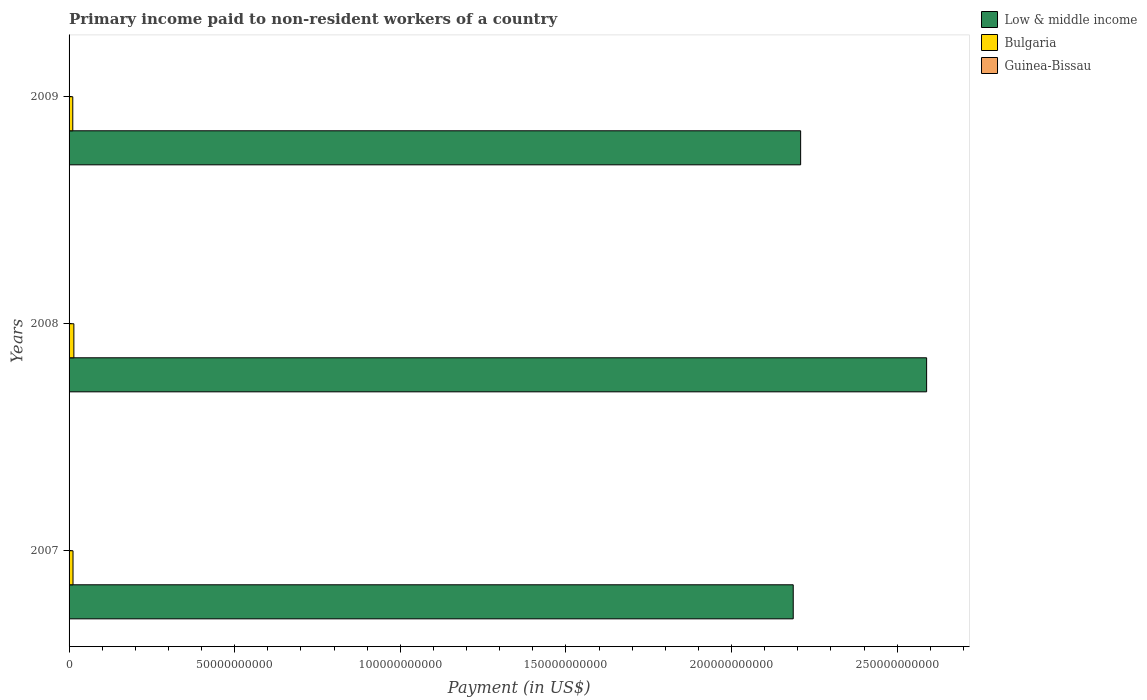Are the number of bars on each tick of the Y-axis equal?
Keep it short and to the point. Yes. How many bars are there on the 3rd tick from the top?
Your answer should be very brief. 3. How many bars are there on the 2nd tick from the bottom?
Make the answer very short. 3. What is the label of the 2nd group of bars from the top?
Make the answer very short. 2008. In how many cases, is the number of bars for a given year not equal to the number of legend labels?
Provide a short and direct response. 0. What is the amount paid to workers in Bulgaria in 2007?
Offer a very short reply. 1.19e+09. Across all years, what is the maximum amount paid to workers in Low & middle income?
Your response must be concise. 2.59e+11. Across all years, what is the minimum amount paid to workers in Low & middle income?
Your response must be concise. 2.19e+11. In which year was the amount paid to workers in Guinea-Bissau maximum?
Your answer should be very brief. 2009. In which year was the amount paid to workers in Low & middle income minimum?
Offer a very short reply. 2007. What is the total amount paid to workers in Guinea-Bissau in the graph?
Offer a very short reply. 9.26e+06. What is the difference between the amount paid to workers in Guinea-Bissau in 2007 and that in 2008?
Make the answer very short. 2.60e+05. What is the difference between the amount paid to workers in Low & middle income in 2009 and the amount paid to workers in Guinea-Bissau in 2007?
Offer a terse response. 2.21e+11. What is the average amount paid to workers in Guinea-Bissau per year?
Ensure brevity in your answer.  3.09e+06. In the year 2007, what is the difference between the amount paid to workers in Guinea-Bissau and amount paid to workers in Low & middle income?
Offer a very short reply. -2.19e+11. What is the ratio of the amount paid to workers in Low & middle income in 2008 to that in 2009?
Offer a terse response. 1.17. Is the amount paid to workers in Bulgaria in 2007 less than that in 2009?
Your answer should be very brief. No. What is the difference between the highest and the second highest amount paid to workers in Guinea-Bissau?
Your response must be concise. 8.20e+06. What is the difference between the highest and the lowest amount paid to workers in Guinea-Bissau?
Keep it short and to the point. 8.46e+06. Is the sum of the amount paid to workers in Low & middle income in 2007 and 2008 greater than the maximum amount paid to workers in Bulgaria across all years?
Offer a very short reply. Yes. What does the 2nd bar from the top in 2009 represents?
Make the answer very short. Bulgaria. What does the 3rd bar from the bottom in 2008 represents?
Provide a short and direct response. Guinea-Bissau. How many bars are there?
Offer a terse response. 9. How many years are there in the graph?
Offer a terse response. 3. What is the difference between two consecutive major ticks on the X-axis?
Your answer should be compact. 5.00e+1. Are the values on the major ticks of X-axis written in scientific E-notation?
Make the answer very short. No. How many legend labels are there?
Your response must be concise. 3. How are the legend labels stacked?
Make the answer very short. Vertical. What is the title of the graph?
Offer a very short reply. Primary income paid to non-resident workers of a country. What is the label or title of the X-axis?
Give a very brief answer. Payment (in US$). What is the Payment (in US$) of Low & middle income in 2007?
Ensure brevity in your answer.  2.19e+11. What is the Payment (in US$) in Bulgaria in 2007?
Offer a very short reply. 1.19e+09. What is the Payment (in US$) in Guinea-Bissau in 2007?
Offer a very short reply. 4.40e+05. What is the Payment (in US$) in Low & middle income in 2008?
Keep it short and to the point. 2.59e+11. What is the Payment (in US$) in Bulgaria in 2008?
Make the answer very short. 1.45e+09. What is the Payment (in US$) in Guinea-Bissau in 2008?
Your answer should be compact. 1.80e+05. What is the Payment (in US$) in Low & middle income in 2009?
Keep it short and to the point. 2.21e+11. What is the Payment (in US$) of Bulgaria in 2009?
Your answer should be very brief. 1.12e+09. What is the Payment (in US$) in Guinea-Bissau in 2009?
Give a very brief answer. 8.64e+06. Across all years, what is the maximum Payment (in US$) of Low & middle income?
Give a very brief answer. 2.59e+11. Across all years, what is the maximum Payment (in US$) of Bulgaria?
Offer a very short reply. 1.45e+09. Across all years, what is the maximum Payment (in US$) in Guinea-Bissau?
Ensure brevity in your answer.  8.64e+06. Across all years, what is the minimum Payment (in US$) in Low & middle income?
Offer a very short reply. 2.19e+11. Across all years, what is the minimum Payment (in US$) of Bulgaria?
Give a very brief answer. 1.12e+09. Across all years, what is the minimum Payment (in US$) of Guinea-Bissau?
Your answer should be very brief. 1.80e+05. What is the total Payment (in US$) in Low & middle income in the graph?
Make the answer very short. 6.98e+11. What is the total Payment (in US$) in Bulgaria in the graph?
Give a very brief answer. 3.76e+09. What is the total Payment (in US$) in Guinea-Bissau in the graph?
Offer a terse response. 9.26e+06. What is the difference between the Payment (in US$) in Low & middle income in 2007 and that in 2008?
Make the answer very short. -4.03e+1. What is the difference between the Payment (in US$) of Bulgaria in 2007 and that in 2008?
Provide a succinct answer. -2.61e+08. What is the difference between the Payment (in US$) of Guinea-Bissau in 2007 and that in 2008?
Offer a terse response. 2.60e+05. What is the difference between the Payment (in US$) of Low & middle income in 2007 and that in 2009?
Make the answer very short. -2.24e+09. What is the difference between the Payment (in US$) in Bulgaria in 2007 and that in 2009?
Provide a short and direct response. 6.98e+07. What is the difference between the Payment (in US$) in Guinea-Bissau in 2007 and that in 2009?
Your answer should be compact. -8.20e+06. What is the difference between the Payment (in US$) in Low & middle income in 2008 and that in 2009?
Your response must be concise. 3.80e+1. What is the difference between the Payment (in US$) in Bulgaria in 2008 and that in 2009?
Ensure brevity in your answer.  3.31e+08. What is the difference between the Payment (in US$) in Guinea-Bissau in 2008 and that in 2009?
Offer a terse response. -8.46e+06. What is the difference between the Payment (in US$) of Low & middle income in 2007 and the Payment (in US$) of Bulgaria in 2008?
Provide a short and direct response. 2.17e+11. What is the difference between the Payment (in US$) in Low & middle income in 2007 and the Payment (in US$) in Guinea-Bissau in 2008?
Your response must be concise. 2.19e+11. What is the difference between the Payment (in US$) of Bulgaria in 2007 and the Payment (in US$) of Guinea-Bissau in 2008?
Offer a very short reply. 1.19e+09. What is the difference between the Payment (in US$) in Low & middle income in 2007 and the Payment (in US$) in Bulgaria in 2009?
Offer a very short reply. 2.18e+11. What is the difference between the Payment (in US$) of Low & middle income in 2007 and the Payment (in US$) of Guinea-Bissau in 2009?
Provide a short and direct response. 2.19e+11. What is the difference between the Payment (in US$) of Bulgaria in 2007 and the Payment (in US$) of Guinea-Bissau in 2009?
Provide a short and direct response. 1.18e+09. What is the difference between the Payment (in US$) of Low & middle income in 2008 and the Payment (in US$) of Bulgaria in 2009?
Your answer should be very brief. 2.58e+11. What is the difference between the Payment (in US$) of Low & middle income in 2008 and the Payment (in US$) of Guinea-Bissau in 2009?
Offer a terse response. 2.59e+11. What is the difference between the Payment (in US$) in Bulgaria in 2008 and the Payment (in US$) in Guinea-Bissau in 2009?
Your answer should be compact. 1.44e+09. What is the average Payment (in US$) in Low & middle income per year?
Give a very brief answer. 2.33e+11. What is the average Payment (in US$) in Bulgaria per year?
Offer a very short reply. 1.25e+09. What is the average Payment (in US$) in Guinea-Bissau per year?
Offer a very short reply. 3.09e+06. In the year 2007, what is the difference between the Payment (in US$) of Low & middle income and Payment (in US$) of Bulgaria?
Offer a terse response. 2.17e+11. In the year 2007, what is the difference between the Payment (in US$) of Low & middle income and Payment (in US$) of Guinea-Bissau?
Keep it short and to the point. 2.19e+11. In the year 2007, what is the difference between the Payment (in US$) of Bulgaria and Payment (in US$) of Guinea-Bissau?
Provide a short and direct response. 1.19e+09. In the year 2008, what is the difference between the Payment (in US$) in Low & middle income and Payment (in US$) in Bulgaria?
Ensure brevity in your answer.  2.57e+11. In the year 2008, what is the difference between the Payment (in US$) in Low & middle income and Payment (in US$) in Guinea-Bissau?
Keep it short and to the point. 2.59e+11. In the year 2008, what is the difference between the Payment (in US$) of Bulgaria and Payment (in US$) of Guinea-Bissau?
Make the answer very short. 1.45e+09. In the year 2009, what is the difference between the Payment (in US$) of Low & middle income and Payment (in US$) of Bulgaria?
Your answer should be very brief. 2.20e+11. In the year 2009, what is the difference between the Payment (in US$) of Low & middle income and Payment (in US$) of Guinea-Bissau?
Your answer should be compact. 2.21e+11. In the year 2009, what is the difference between the Payment (in US$) of Bulgaria and Payment (in US$) of Guinea-Bissau?
Your answer should be very brief. 1.11e+09. What is the ratio of the Payment (in US$) in Low & middle income in 2007 to that in 2008?
Keep it short and to the point. 0.84. What is the ratio of the Payment (in US$) in Bulgaria in 2007 to that in 2008?
Your answer should be compact. 0.82. What is the ratio of the Payment (in US$) in Guinea-Bissau in 2007 to that in 2008?
Your answer should be very brief. 2.44. What is the ratio of the Payment (in US$) in Low & middle income in 2007 to that in 2009?
Provide a short and direct response. 0.99. What is the ratio of the Payment (in US$) in Bulgaria in 2007 to that in 2009?
Ensure brevity in your answer.  1.06. What is the ratio of the Payment (in US$) of Guinea-Bissau in 2007 to that in 2009?
Your response must be concise. 0.05. What is the ratio of the Payment (in US$) in Low & middle income in 2008 to that in 2009?
Your answer should be compact. 1.17. What is the ratio of the Payment (in US$) of Bulgaria in 2008 to that in 2009?
Your response must be concise. 1.3. What is the ratio of the Payment (in US$) in Guinea-Bissau in 2008 to that in 2009?
Your response must be concise. 0.02. What is the difference between the highest and the second highest Payment (in US$) in Low & middle income?
Your answer should be compact. 3.80e+1. What is the difference between the highest and the second highest Payment (in US$) in Bulgaria?
Your response must be concise. 2.61e+08. What is the difference between the highest and the second highest Payment (in US$) in Guinea-Bissau?
Make the answer very short. 8.20e+06. What is the difference between the highest and the lowest Payment (in US$) of Low & middle income?
Offer a terse response. 4.03e+1. What is the difference between the highest and the lowest Payment (in US$) of Bulgaria?
Make the answer very short. 3.31e+08. What is the difference between the highest and the lowest Payment (in US$) in Guinea-Bissau?
Ensure brevity in your answer.  8.46e+06. 